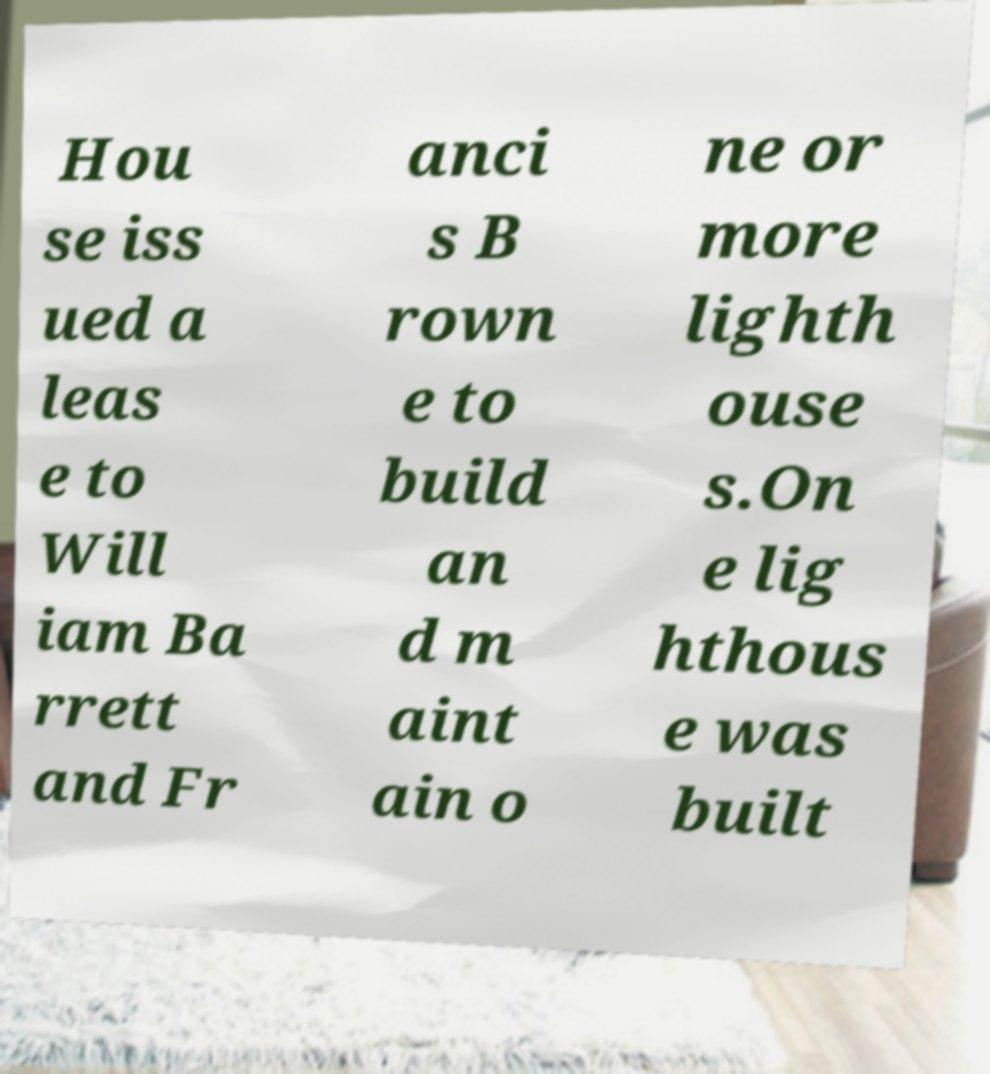For documentation purposes, I need the text within this image transcribed. Could you provide that? Hou se iss ued a leas e to Will iam Ba rrett and Fr anci s B rown e to build an d m aint ain o ne or more lighth ouse s.On e lig hthous e was built 